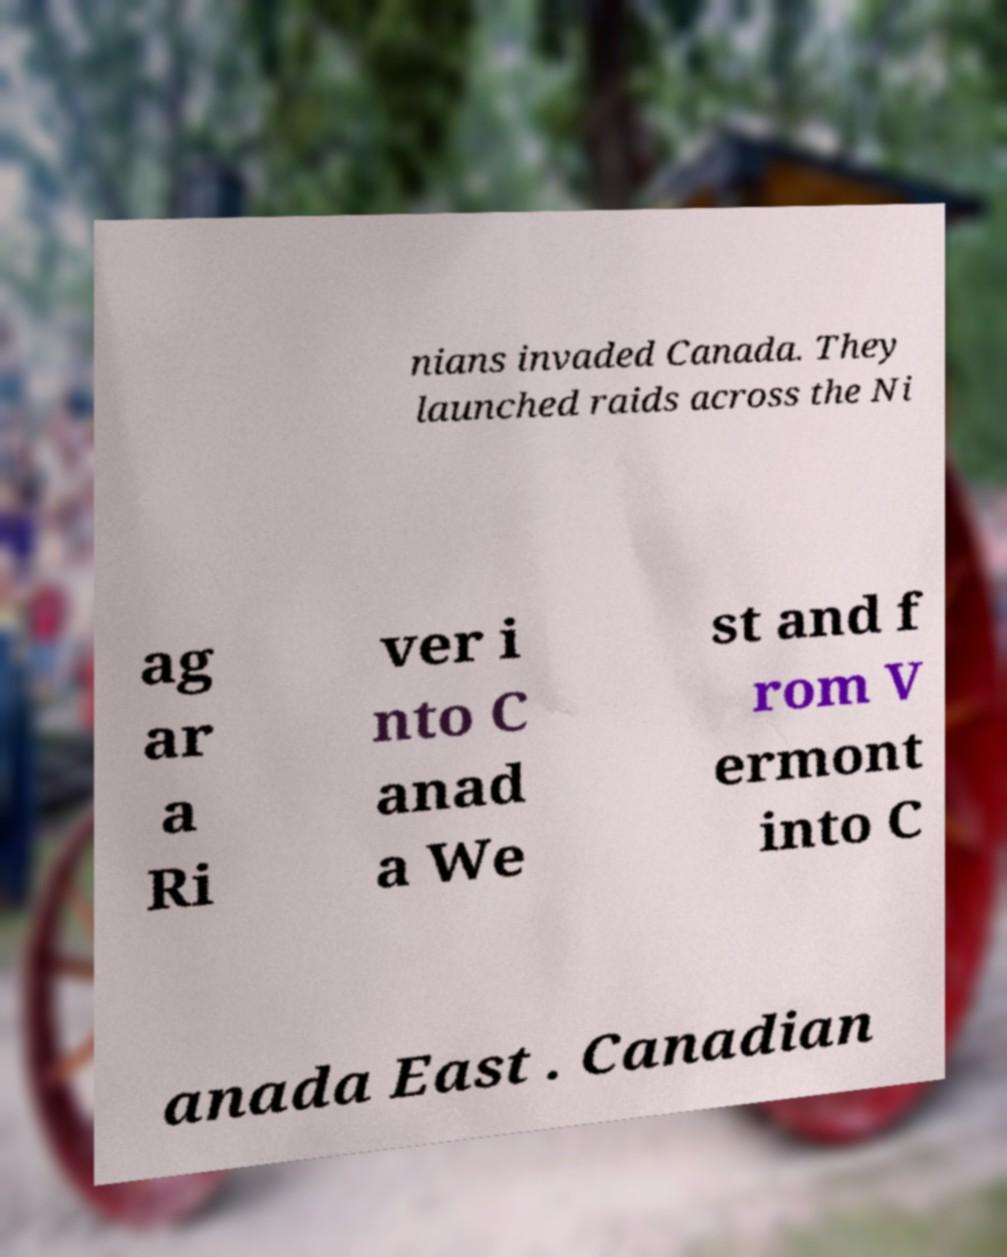For documentation purposes, I need the text within this image transcribed. Could you provide that? nians invaded Canada. They launched raids across the Ni ag ar a Ri ver i nto C anad a We st and f rom V ermont into C anada East . Canadian 